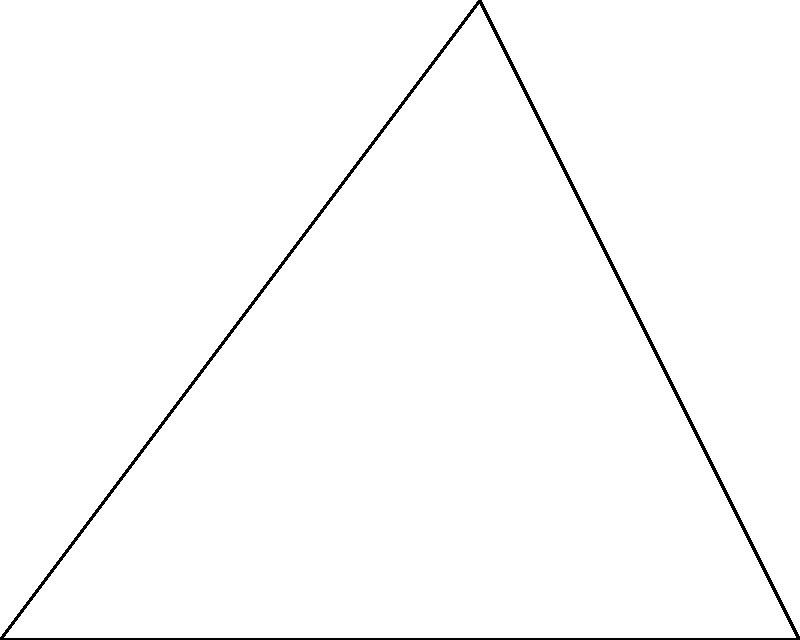As a boxer practicing with a speed bag, you need to determine the angle of the bag's swing for optimal timing. The bag is suspended from point O, and swings from point A to point B. If OA = 5 cm, AB = 4 cm, and OB = 3 cm, what is the angle $\theta$ (in degrees) of the bag's swing? To solve this problem, we'll use the law of cosines. Here's the step-by-step solution:

1) The law of cosines states: $c^2 = a^2 + b^2 - 2ab \cos(C)$, where C is the angle opposite side c.

2) In our triangle, we want to find angle $\theta$, which is opposite side AB. Let's assign:
   a = OB = 3 cm
   b = OA = 5 cm
   c = AB = 4 cm

3) Substituting into the law of cosines:
   $4^2 = 3^2 + 5^2 - 2(3)(5) \cos(\theta)$

4) Simplify:
   $16 = 9 + 25 - 30 \cos(\theta)$
   $16 = 34 - 30 \cos(\theta)$

5) Subtract 34 from both sides:
   $-18 = -30 \cos(\theta)$

6) Divide both sides by -30:
   $\frac{3}{5} = \cos(\theta)$

7) To find $\theta$, we need to take the inverse cosine (arccos) of both sides:
   $\theta = \arccos(\frac{3}{5})$

8) Using a calculator or computer, we can find:
   $\theta \approx 53.13°$

Therefore, the angle of the speed bag's swing is approximately 53.13°.
Answer: $53.13°$ 